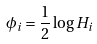Convert formula to latex. <formula><loc_0><loc_0><loc_500><loc_500>\phi _ { i } = \frac { 1 } { 2 } \log H _ { i }</formula> 